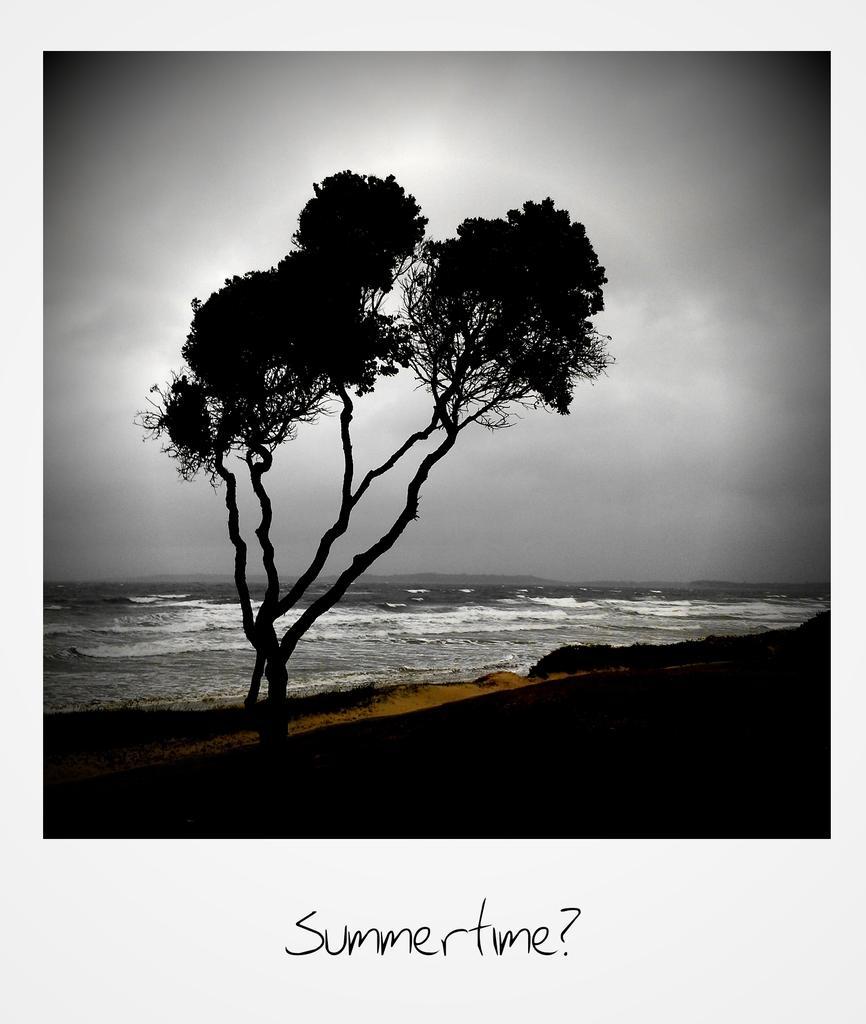How would you summarize this image in a sentence or two? In this image I can see in the middle it looks like there are trees. In the background there is water, at the bottom there is the text. At the top there is the cloudy sky. 